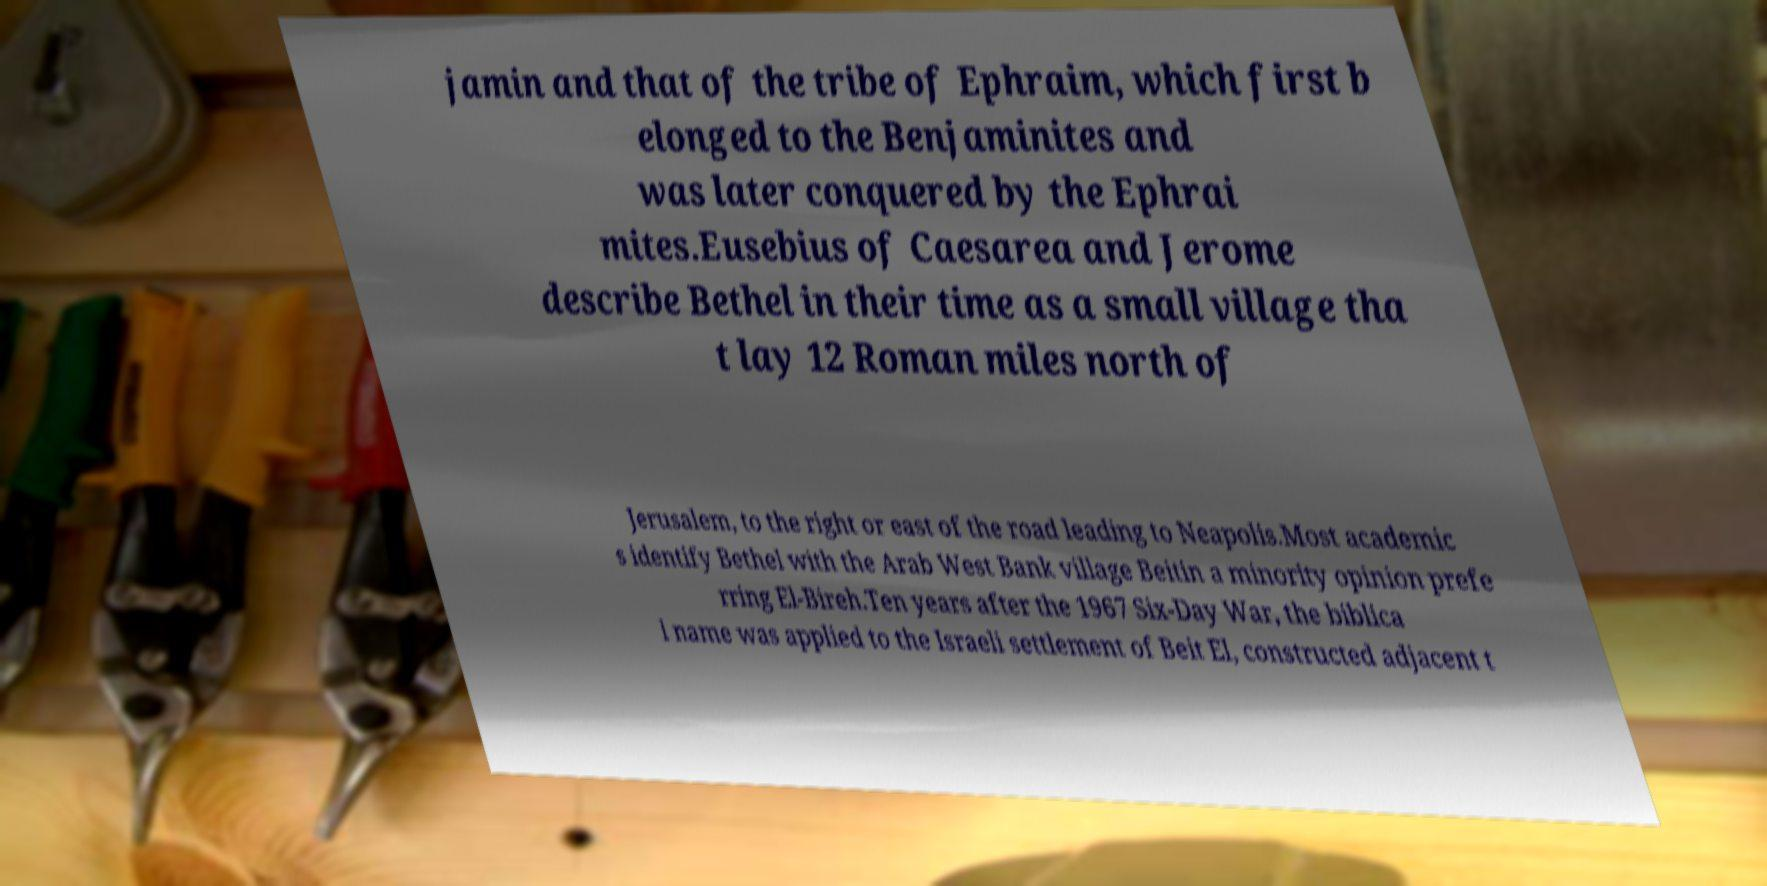Could you extract and type out the text from this image? jamin and that of the tribe of Ephraim, which first b elonged to the Benjaminites and was later conquered by the Ephrai mites.Eusebius of Caesarea and Jerome describe Bethel in their time as a small village tha t lay 12 Roman miles north of Jerusalem, to the right or east of the road leading to Neapolis.Most academic s identify Bethel with the Arab West Bank village Beitin a minority opinion prefe rring El-Bireh.Ten years after the 1967 Six-Day War, the biblica l name was applied to the Israeli settlement of Beit El, constructed adjacent t 